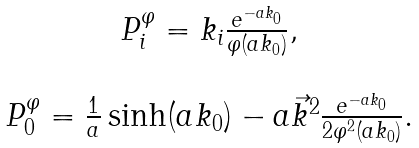<formula> <loc_0><loc_0><loc_500><loc_500>\begin{array} { c } P _ { i } ^ { \varphi } = k _ { i } \frac { e ^ { - a k _ { 0 } } } { \varphi ( a k _ { 0 } ) } , \\ \\ P _ { 0 } ^ { \varphi } = \frac { 1 } { a } \sinh ( a k _ { 0 } ) - a { \vec { k } } ^ { 2 } \frac { e ^ { - a k _ { 0 } } } { 2 \varphi ^ { 2 } ( a k _ { 0 } ) } . \end{array}</formula> 